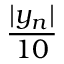Convert formula to latex. <formula><loc_0><loc_0><loc_500><loc_500>\frac { | y _ { n } | } { 1 0 }</formula> 